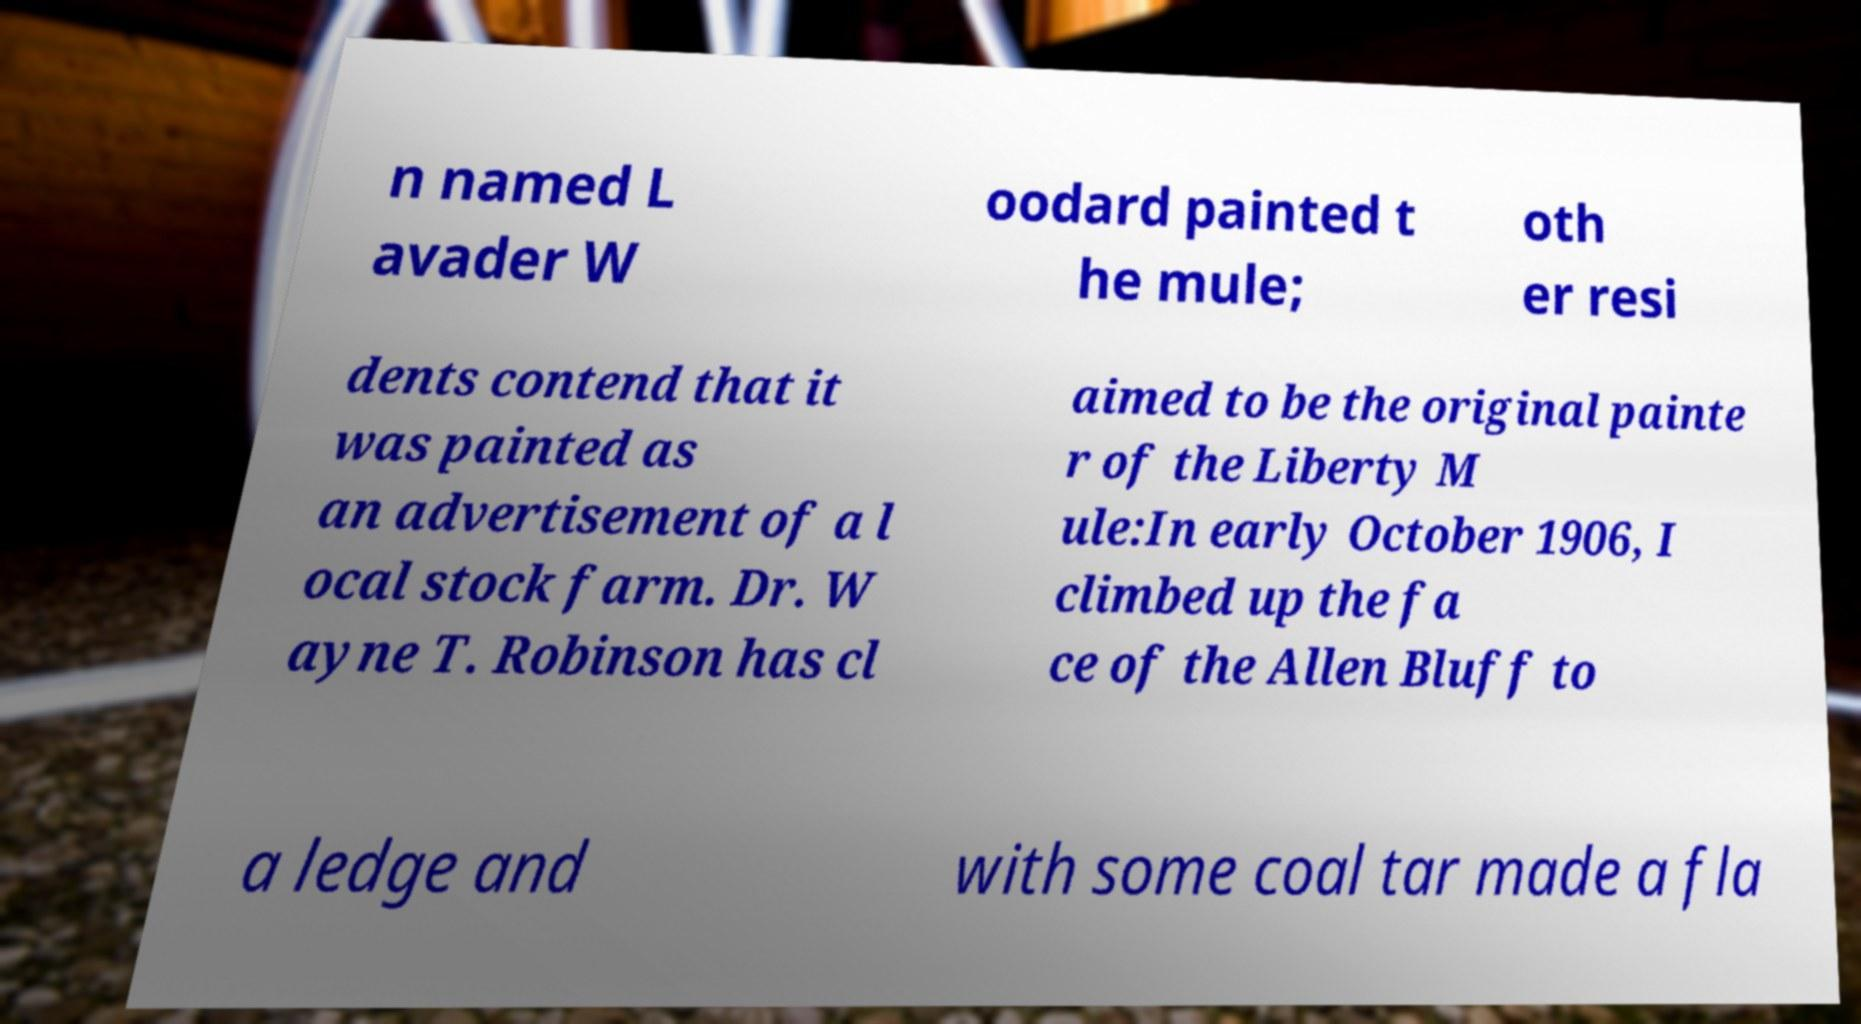Can you accurately transcribe the text from the provided image for me? n named L avader W oodard painted t he mule; oth er resi dents contend that it was painted as an advertisement of a l ocal stock farm. Dr. W ayne T. Robinson has cl aimed to be the original painte r of the Liberty M ule:In early October 1906, I climbed up the fa ce of the Allen Bluff to a ledge and with some coal tar made a fla 